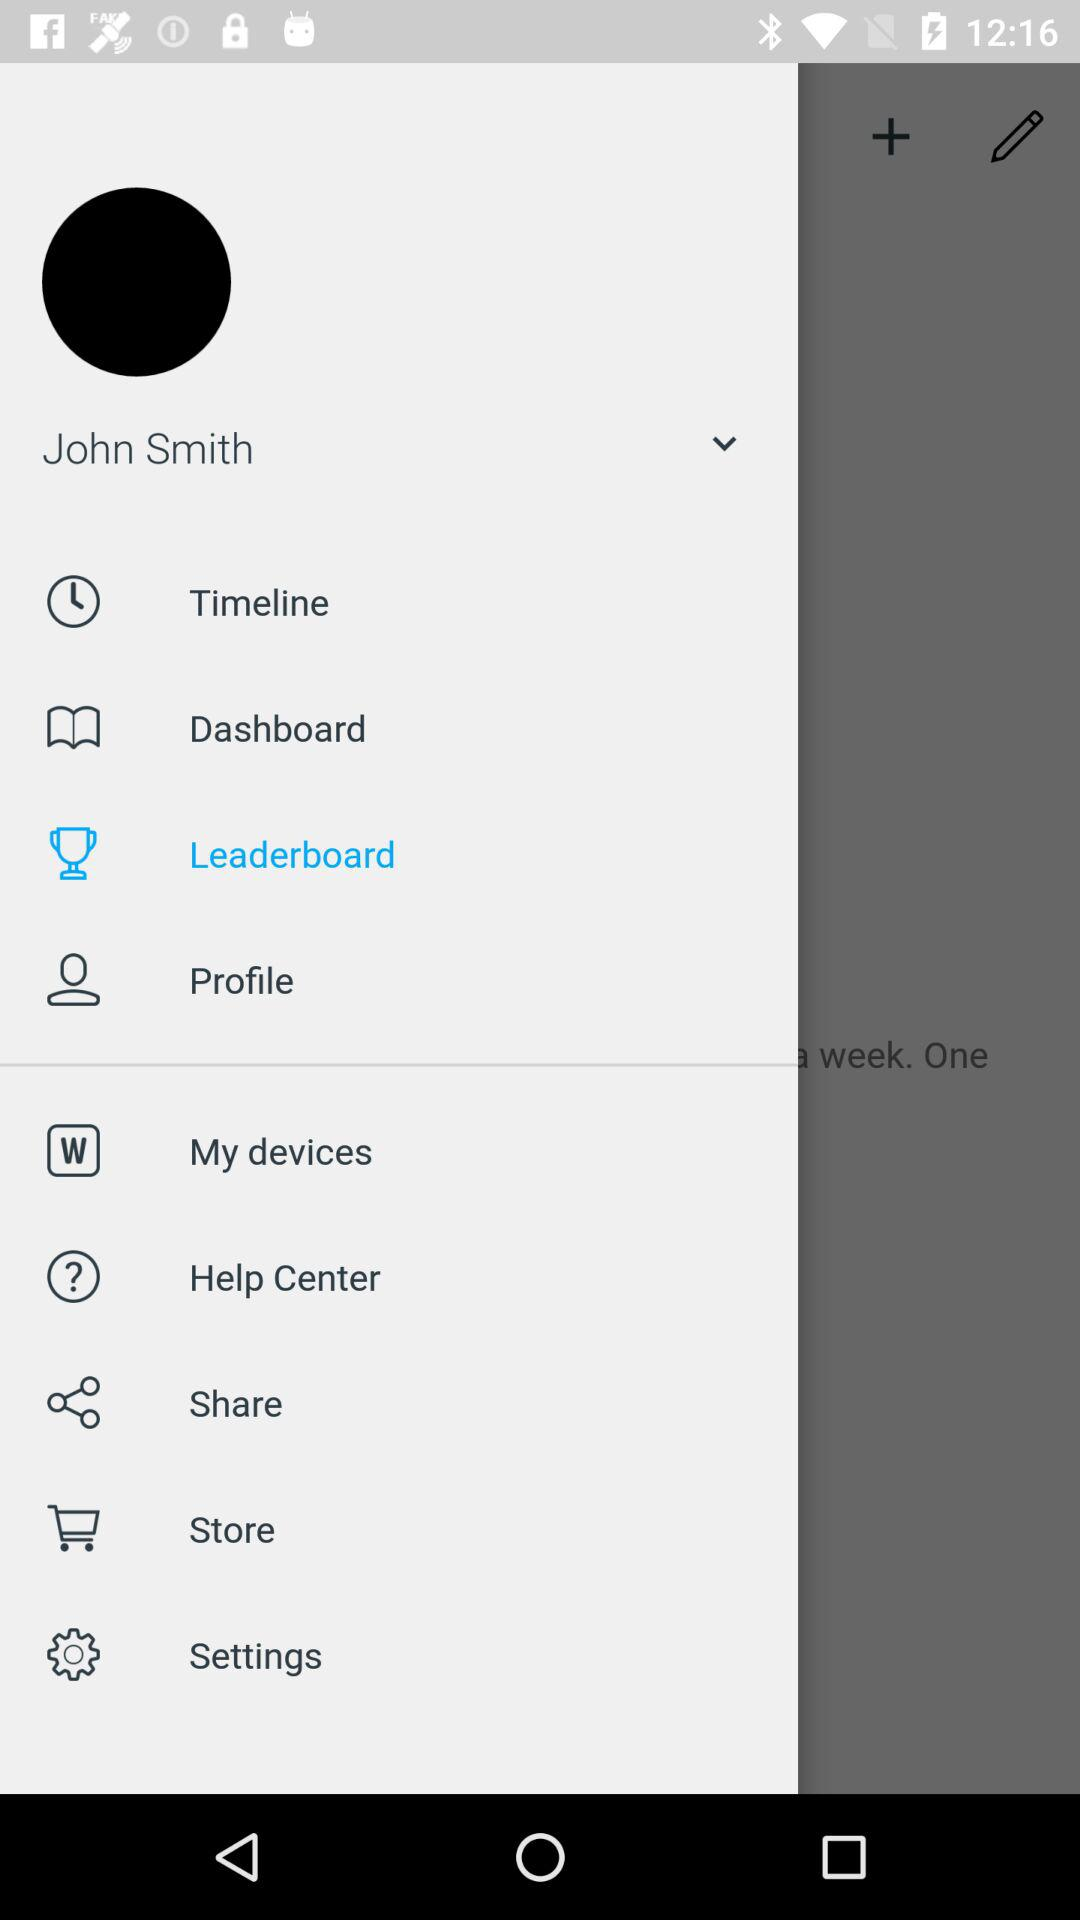What is the user name? The user name is John Smith. 